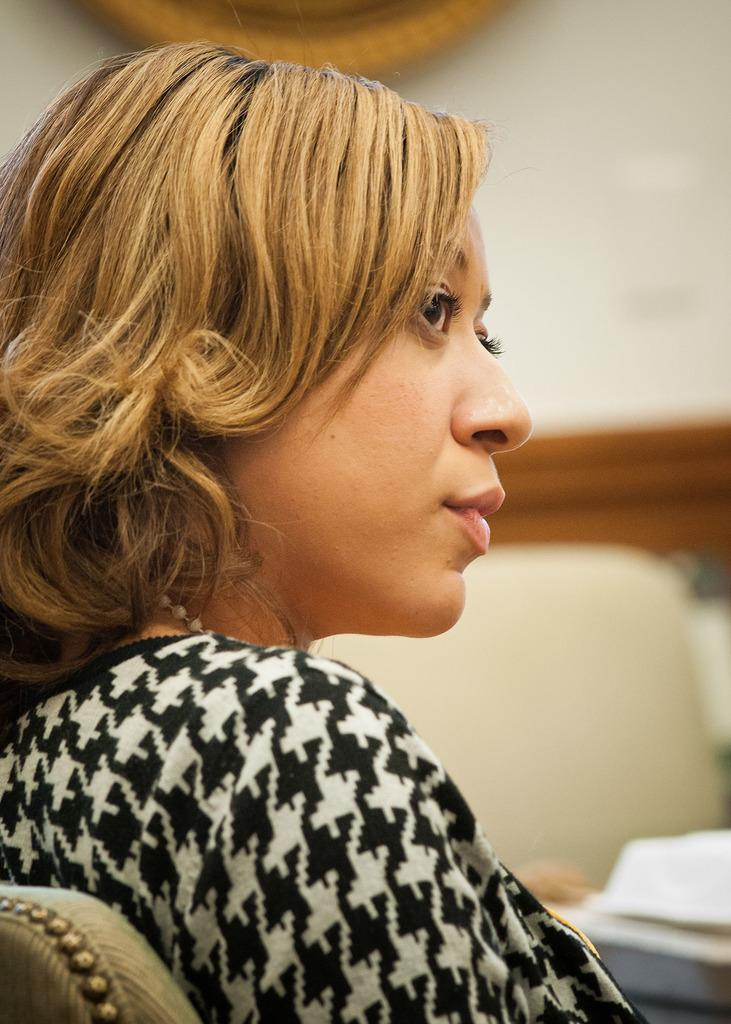What is the main subject of the image? There is a person in the image. What is the person wearing? The person is wearing a black and white dress. Can you describe the background of the image? The background of the image is blurred. How many trees can be seen casting shade on the person in the image? There are no trees visible in the image, so it is not possible to determine how many trees might be casting shade on the person. 